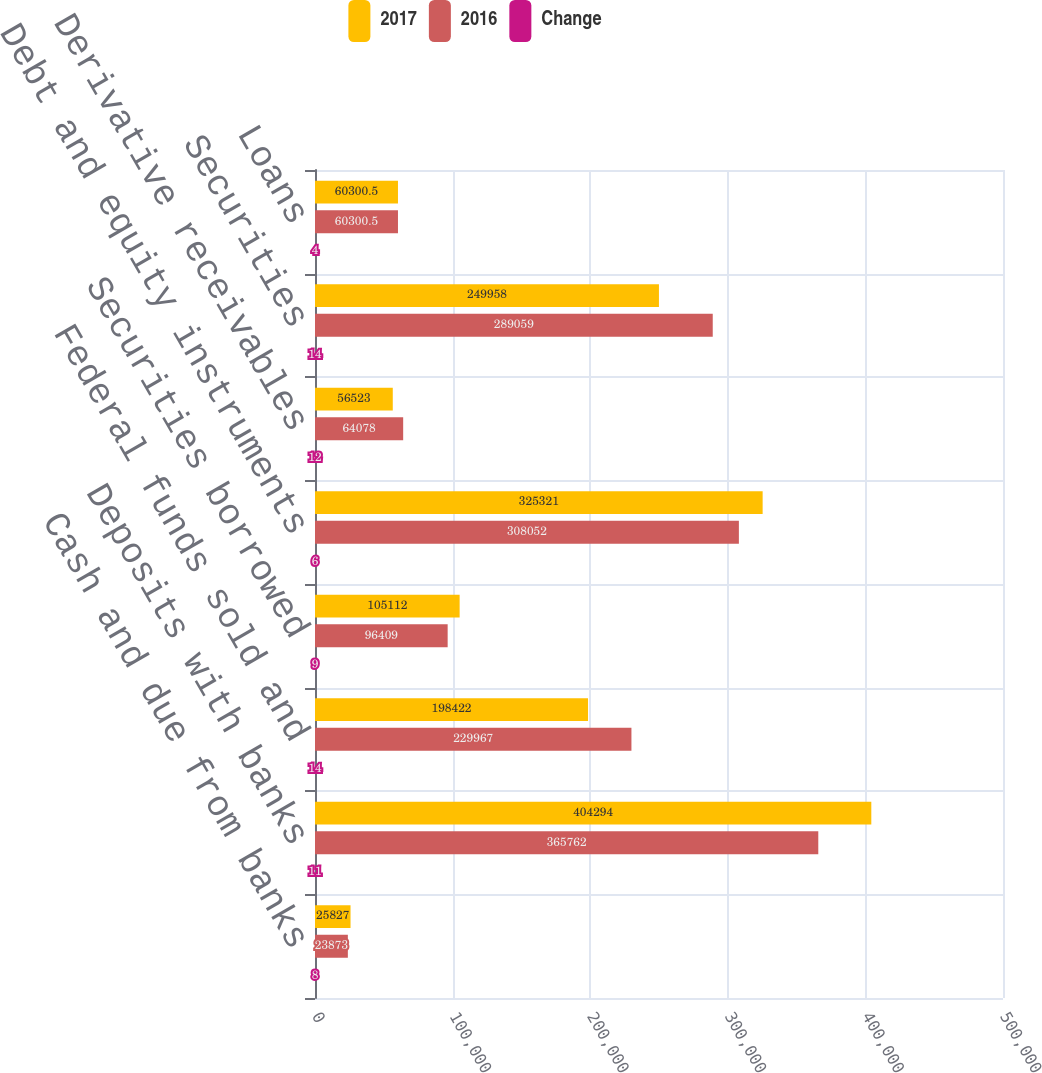Convert chart. <chart><loc_0><loc_0><loc_500><loc_500><stacked_bar_chart><ecel><fcel>Cash and due from banks<fcel>Deposits with banks<fcel>Federal funds sold and<fcel>Securities borrowed<fcel>Debt and equity instruments<fcel>Derivative receivables<fcel>Securities<fcel>Loans<nl><fcel>2017<fcel>25827<fcel>404294<fcel>198422<fcel>105112<fcel>325321<fcel>56523<fcel>249958<fcel>60300.5<nl><fcel>2016<fcel>23873<fcel>365762<fcel>229967<fcel>96409<fcel>308052<fcel>64078<fcel>289059<fcel>60300.5<nl><fcel>Change<fcel>8<fcel>11<fcel>14<fcel>9<fcel>6<fcel>12<fcel>14<fcel>4<nl></chart> 